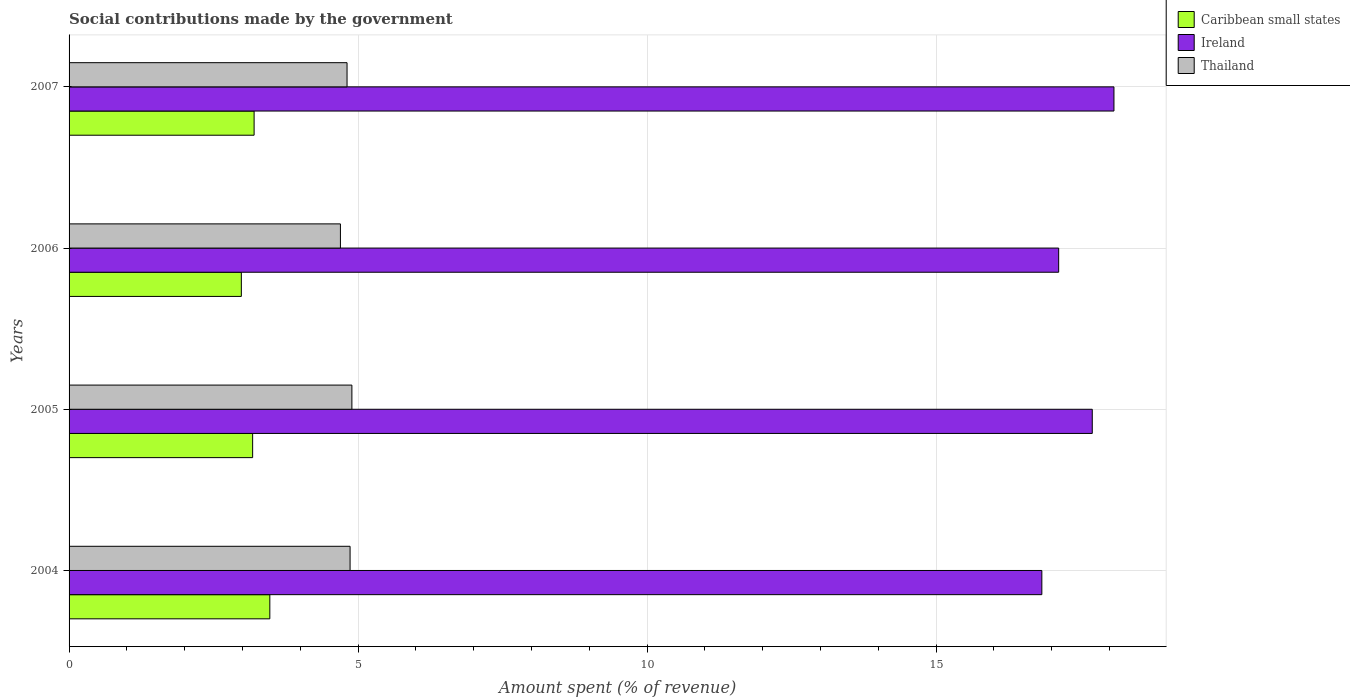Are the number of bars per tick equal to the number of legend labels?
Keep it short and to the point. Yes. How many bars are there on the 2nd tick from the bottom?
Offer a very short reply. 3. What is the label of the 1st group of bars from the top?
Your answer should be compact. 2007. In how many cases, is the number of bars for a given year not equal to the number of legend labels?
Make the answer very short. 0. What is the amount spent (in %) on social contributions in Caribbean small states in 2007?
Offer a very short reply. 3.2. Across all years, what is the maximum amount spent (in %) on social contributions in Ireland?
Keep it short and to the point. 18.08. Across all years, what is the minimum amount spent (in %) on social contributions in Caribbean small states?
Your response must be concise. 2.98. In which year was the amount spent (in %) on social contributions in Ireland maximum?
Your answer should be compact. 2007. What is the total amount spent (in %) on social contributions in Ireland in the graph?
Make the answer very short. 69.73. What is the difference between the amount spent (in %) on social contributions in Thailand in 2004 and that in 2006?
Provide a short and direct response. 0.17. What is the difference between the amount spent (in %) on social contributions in Thailand in 2005 and the amount spent (in %) on social contributions in Caribbean small states in 2007?
Provide a short and direct response. 1.69. What is the average amount spent (in %) on social contributions in Thailand per year?
Provide a succinct answer. 4.81. In the year 2005, what is the difference between the amount spent (in %) on social contributions in Ireland and amount spent (in %) on social contributions in Caribbean small states?
Provide a succinct answer. 14.53. What is the ratio of the amount spent (in %) on social contributions in Caribbean small states in 2004 to that in 2005?
Your answer should be compact. 1.09. Is the amount spent (in %) on social contributions in Caribbean small states in 2004 less than that in 2007?
Your answer should be compact. No. Is the difference between the amount spent (in %) on social contributions in Ireland in 2005 and 2007 greater than the difference between the amount spent (in %) on social contributions in Caribbean small states in 2005 and 2007?
Keep it short and to the point. No. What is the difference between the highest and the second highest amount spent (in %) on social contributions in Caribbean small states?
Make the answer very short. 0.27. What is the difference between the highest and the lowest amount spent (in %) on social contributions in Thailand?
Provide a succinct answer. 0.2. In how many years, is the amount spent (in %) on social contributions in Caribbean small states greater than the average amount spent (in %) on social contributions in Caribbean small states taken over all years?
Give a very brief answer. 1. Is the sum of the amount spent (in %) on social contributions in Ireland in 2005 and 2006 greater than the maximum amount spent (in %) on social contributions in Thailand across all years?
Your answer should be compact. Yes. What does the 2nd bar from the top in 2005 represents?
Offer a very short reply. Ireland. What does the 2nd bar from the bottom in 2007 represents?
Your response must be concise. Ireland. Does the graph contain grids?
Your response must be concise. Yes. How are the legend labels stacked?
Your response must be concise. Vertical. What is the title of the graph?
Provide a short and direct response. Social contributions made by the government. What is the label or title of the X-axis?
Provide a succinct answer. Amount spent (% of revenue). What is the label or title of the Y-axis?
Offer a very short reply. Years. What is the Amount spent (% of revenue) in Caribbean small states in 2004?
Provide a short and direct response. 3.47. What is the Amount spent (% of revenue) in Ireland in 2004?
Offer a very short reply. 16.83. What is the Amount spent (% of revenue) in Thailand in 2004?
Your response must be concise. 4.86. What is the Amount spent (% of revenue) of Caribbean small states in 2005?
Keep it short and to the point. 3.18. What is the Amount spent (% of revenue) in Ireland in 2005?
Your response must be concise. 17.7. What is the Amount spent (% of revenue) in Thailand in 2005?
Give a very brief answer. 4.89. What is the Amount spent (% of revenue) of Caribbean small states in 2006?
Offer a very short reply. 2.98. What is the Amount spent (% of revenue) in Ireland in 2006?
Make the answer very short. 17.12. What is the Amount spent (% of revenue) of Thailand in 2006?
Your answer should be compact. 4.69. What is the Amount spent (% of revenue) in Caribbean small states in 2007?
Your answer should be compact. 3.2. What is the Amount spent (% of revenue) of Ireland in 2007?
Give a very brief answer. 18.08. What is the Amount spent (% of revenue) in Thailand in 2007?
Provide a succinct answer. 4.81. Across all years, what is the maximum Amount spent (% of revenue) of Caribbean small states?
Provide a short and direct response. 3.47. Across all years, what is the maximum Amount spent (% of revenue) in Ireland?
Offer a terse response. 18.08. Across all years, what is the maximum Amount spent (% of revenue) of Thailand?
Your answer should be very brief. 4.89. Across all years, what is the minimum Amount spent (% of revenue) in Caribbean small states?
Make the answer very short. 2.98. Across all years, what is the minimum Amount spent (% of revenue) of Ireland?
Your response must be concise. 16.83. Across all years, what is the minimum Amount spent (% of revenue) in Thailand?
Offer a terse response. 4.69. What is the total Amount spent (% of revenue) in Caribbean small states in the graph?
Offer a very short reply. 12.83. What is the total Amount spent (% of revenue) in Ireland in the graph?
Make the answer very short. 69.73. What is the total Amount spent (% of revenue) of Thailand in the graph?
Make the answer very short. 19.26. What is the difference between the Amount spent (% of revenue) in Caribbean small states in 2004 and that in 2005?
Offer a very short reply. 0.3. What is the difference between the Amount spent (% of revenue) of Ireland in 2004 and that in 2005?
Ensure brevity in your answer.  -0.87. What is the difference between the Amount spent (% of revenue) of Thailand in 2004 and that in 2005?
Provide a short and direct response. -0.03. What is the difference between the Amount spent (% of revenue) of Caribbean small states in 2004 and that in 2006?
Ensure brevity in your answer.  0.49. What is the difference between the Amount spent (% of revenue) in Ireland in 2004 and that in 2006?
Offer a terse response. -0.29. What is the difference between the Amount spent (% of revenue) in Thailand in 2004 and that in 2006?
Offer a very short reply. 0.17. What is the difference between the Amount spent (% of revenue) in Caribbean small states in 2004 and that in 2007?
Offer a terse response. 0.27. What is the difference between the Amount spent (% of revenue) of Ireland in 2004 and that in 2007?
Your response must be concise. -1.25. What is the difference between the Amount spent (% of revenue) in Thailand in 2004 and that in 2007?
Your answer should be very brief. 0.05. What is the difference between the Amount spent (% of revenue) of Caribbean small states in 2005 and that in 2006?
Offer a very short reply. 0.2. What is the difference between the Amount spent (% of revenue) of Ireland in 2005 and that in 2006?
Provide a succinct answer. 0.58. What is the difference between the Amount spent (% of revenue) of Thailand in 2005 and that in 2006?
Keep it short and to the point. 0.2. What is the difference between the Amount spent (% of revenue) of Caribbean small states in 2005 and that in 2007?
Your answer should be compact. -0.03. What is the difference between the Amount spent (% of revenue) of Ireland in 2005 and that in 2007?
Make the answer very short. -0.38. What is the difference between the Amount spent (% of revenue) in Thailand in 2005 and that in 2007?
Provide a short and direct response. 0.08. What is the difference between the Amount spent (% of revenue) of Caribbean small states in 2006 and that in 2007?
Ensure brevity in your answer.  -0.22. What is the difference between the Amount spent (% of revenue) in Ireland in 2006 and that in 2007?
Your answer should be compact. -0.96. What is the difference between the Amount spent (% of revenue) in Thailand in 2006 and that in 2007?
Your response must be concise. -0.11. What is the difference between the Amount spent (% of revenue) of Caribbean small states in 2004 and the Amount spent (% of revenue) of Ireland in 2005?
Your response must be concise. -14.23. What is the difference between the Amount spent (% of revenue) in Caribbean small states in 2004 and the Amount spent (% of revenue) in Thailand in 2005?
Your response must be concise. -1.42. What is the difference between the Amount spent (% of revenue) in Ireland in 2004 and the Amount spent (% of revenue) in Thailand in 2005?
Your answer should be compact. 11.94. What is the difference between the Amount spent (% of revenue) of Caribbean small states in 2004 and the Amount spent (% of revenue) of Ireland in 2006?
Keep it short and to the point. -13.65. What is the difference between the Amount spent (% of revenue) in Caribbean small states in 2004 and the Amount spent (% of revenue) in Thailand in 2006?
Offer a very short reply. -1.22. What is the difference between the Amount spent (% of revenue) in Ireland in 2004 and the Amount spent (% of revenue) in Thailand in 2006?
Make the answer very short. 12.14. What is the difference between the Amount spent (% of revenue) of Caribbean small states in 2004 and the Amount spent (% of revenue) of Ireland in 2007?
Offer a terse response. -14.61. What is the difference between the Amount spent (% of revenue) in Caribbean small states in 2004 and the Amount spent (% of revenue) in Thailand in 2007?
Your answer should be compact. -1.34. What is the difference between the Amount spent (% of revenue) of Ireland in 2004 and the Amount spent (% of revenue) of Thailand in 2007?
Offer a very short reply. 12.02. What is the difference between the Amount spent (% of revenue) of Caribbean small states in 2005 and the Amount spent (% of revenue) of Ireland in 2006?
Your answer should be compact. -13.95. What is the difference between the Amount spent (% of revenue) of Caribbean small states in 2005 and the Amount spent (% of revenue) of Thailand in 2006?
Ensure brevity in your answer.  -1.52. What is the difference between the Amount spent (% of revenue) in Ireland in 2005 and the Amount spent (% of revenue) in Thailand in 2006?
Your answer should be very brief. 13.01. What is the difference between the Amount spent (% of revenue) of Caribbean small states in 2005 and the Amount spent (% of revenue) of Ireland in 2007?
Give a very brief answer. -14.9. What is the difference between the Amount spent (% of revenue) of Caribbean small states in 2005 and the Amount spent (% of revenue) of Thailand in 2007?
Provide a succinct answer. -1.63. What is the difference between the Amount spent (% of revenue) in Ireland in 2005 and the Amount spent (% of revenue) in Thailand in 2007?
Provide a succinct answer. 12.89. What is the difference between the Amount spent (% of revenue) in Caribbean small states in 2006 and the Amount spent (% of revenue) in Ireland in 2007?
Provide a short and direct response. -15.1. What is the difference between the Amount spent (% of revenue) of Caribbean small states in 2006 and the Amount spent (% of revenue) of Thailand in 2007?
Your answer should be very brief. -1.83. What is the difference between the Amount spent (% of revenue) of Ireland in 2006 and the Amount spent (% of revenue) of Thailand in 2007?
Offer a terse response. 12.31. What is the average Amount spent (% of revenue) in Caribbean small states per year?
Offer a terse response. 3.21. What is the average Amount spent (% of revenue) in Ireland per year?
Provide a succinct answer. 17.43. What is the average Amount spent (% of revenue) of Thailand per year?
Provide a short and direct response. 4.82. In the year 2004, what is the difference between the Amount spent (% of revenue) of Caribbean small states and Amount spent (% of revenue) of Ireland?
Give a very brief answer. -13.36. In the year 2004, what is the difference between the Amount spent (% of revenue) in Caribbean small states and Amount spent (% of revenue) in Thailand?
Provide a succinct answer. -1.39. In the year 2004, what is the difference between the Amount spent (% of revenue) of Ireland and Amount spent (% of revenue) of Thailand?
Ensure brevity in your answer.  11.97. In the year 2005, what is the difference between the Amount spent (% of revenue) in Caribbean small states and Amount spent (% of revenue) in Ireland?
Your answer should be compact. -14.53. In the year 2005, what is the difference between the Amount spent (% of revenue) in Caribbean small states and Amount spent (% of revenue) in Thailand?
Offer a terse response. -1.72. In the year 2005, what is the difference between the Amount spent (% of revenue) of Ireland and Amount spent (% of revenue) of Thailand?
Give a very brief answer. 12.81. In the year 2006, what is the difference between the Amount spent (% of revenue) of Caribbean small states and Amount spent (% of revenue) of Ireland?
Give a very brief answer. -14.14. In the year 2006, what is the difference between the Amount spent (% of revenue) in Caribbean small states and Amount spent (% of revenue) in Thailand?
Your answer should be compact. -1.71. In the year 2006, what is the difference between the Amount spent (% of revenue) of Ireland and Amount spent (% of revenue) of Thailand?
Your answer should be compact. 12.43. In the year 2007, what is the difference between the Amount spent (% of revenue) in Caribbean small states and Amount spent (% of revenue) in Ireland?
Offer a terse response. -14.88. In the year 2007, what is the difference between the Amount spent (% of revenue) in Caribbean small states and Amount spent (% of revenue) in Thailand?
Provide a succinct answer. -1.61. In the year 2007, what is the difference between the Amount spent (% of revenue) in Ireland and Amount spent (% of revenue) in Thailand?
Keep it short and to the point. 13.27. What is the ratio of the Amount spent (% of revenue) of Caribbean small states in 2004 to that in 2005?
Give a very brief answer. 1.09. What is the ratio of the Amount spent (% of revenue) of Ireland in 2004 to that in 2005?
Give a very brief answer. 0.95. What is the ratio of the Amount spent (% of revenue) in Caribbean small states in 2004 to that in 2006?
Provide a succinct answer. 1.17. What is the ratio of the Amount spent (% of revenue) of Thailand in 2004 to that in 2006?
Give a very brief answer. 1.04. What is the ratio of the Amount spent (% of revenue) of Caribbean small states in 2004 to that in 2007?
Make the answer very short. 1.08. What is the ratio of the Amount spent (% of revenue) in Thailand in 2004 to that in 2007?
Keep it short and to the point. 1.01. What is the ratio of the Amount spent (% of revenue) of Caribbean small states in 2005 to that in 2006?
Your response must be concise. 1.07. What is the ratio of the Amount spent (% of revenue) of Ireland in 2005 to that in 2006?
Provide a succinct answer. 1.03. What is the ratio of the Amount spent (% of revenue) of Thailand in 2005 to that in 2006?
Your answer should be very brief. 1.04. What is the ratio of the Amount spent (% of revenue) of Ireland in 2005 to that in 2007?
Give a very brief answer. 0.98. What is the ratio of the Amount spent (% of revenue) of Thailand in 2005 to that in 2007?
Your answer should be very brief. 1.02. What is the ratio of the Amount spent (% of revenue) of Caribbean small states in 2006 to that in 2007?
Offer a very short reply. 0.93. What is the ratio of the Amount spent (% of revenue) in Ireland in 2006 to that in 2007?
Provide a succinct answer. 0.95. What is the ratio of the Amount spent (% of revenue) of Thailand in 2006 to that in 2007?
Provide a succinct answer. 0.98. What is the difference between the highest and the second highest Amount spent (% of revenue) in Caribbean small states?
Your answer should be very brief. 0.27. What is the difference between the highest and the second highest Amount spent (% of revenue) of Ireland?
Offer a terse response. 0.38. What is the difference between the highest and the second highest Amount spent (% of revenue) in Thailand?
Offer a terse response. 0.03. What is the difference between the highest and the lowest Amount spent (% of revenue) of Caribbean small states?
Make the answer very short. 0.49. What is the difference between the highest and the lowest Amount spent (% of revenue) of Ireland?
Your answer should be very brief. 1.25. What is the difference between the highest and the lowest Amount spent (% of revenue) in Thailand?
Offer a very short reply. 0.2. 